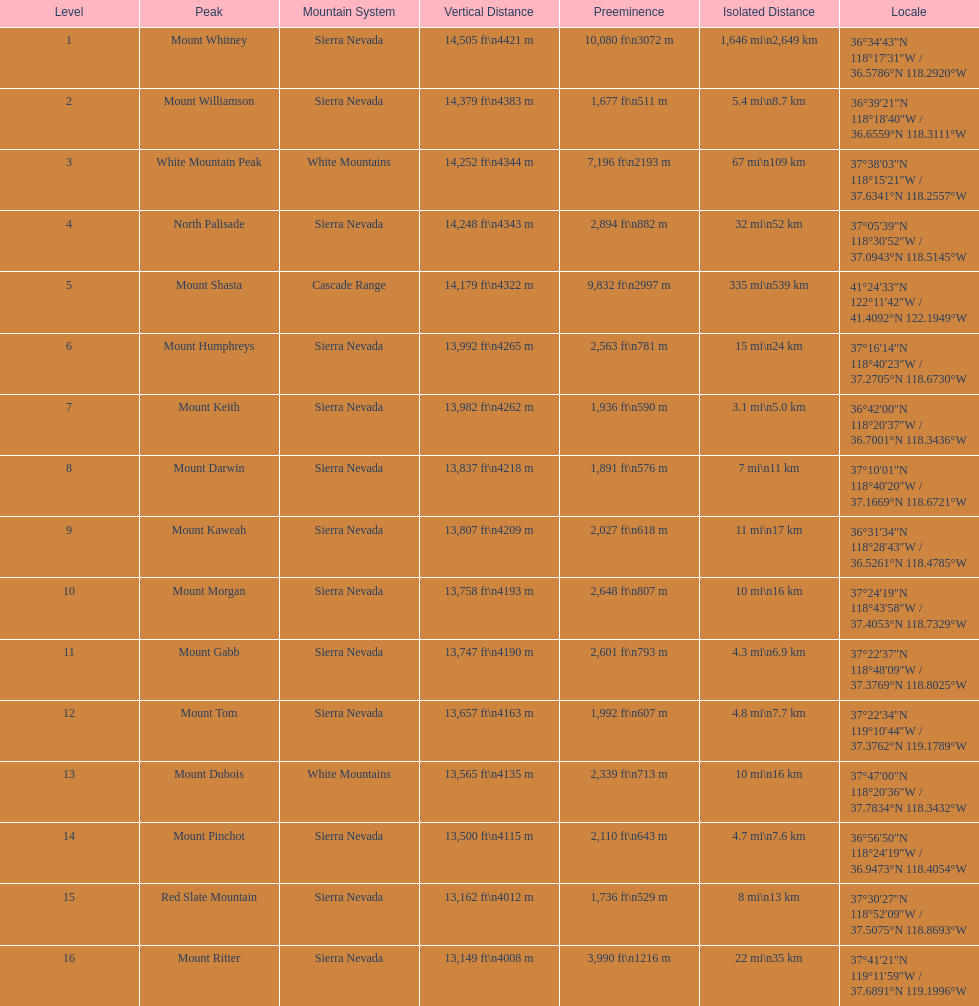Parse the full table. {'header': ['Level', 'Peak', 'Mountain System', 'Vertical Distance', 'Preeminence', 'Isolated Distance', 'Locale'], 'rows': [['1', 'Mount Whitney', 'Sierra Nevada', '14,505\xa0ft\\n4421\xa0m', '10,080\xa0ft\\n3072\xa0m', '1,646\xa0mi\\n2,649\xa0km', '36°34′43″N 118°17′31″W\ufeff / \ufeff36.5786°N 118.2920°W'], ['2', 'Mount Williamson', 'Sierra Nevada', '14,379\xa0ft\\n4383\xa0m', '1,677\xa0ft\\n511\xa0m', '5.4\xa0mi\\n8.7\xa0km', '36°39′21″N 118°18′40″W\ufeff / \ufeff36.6559°N 118.3111°W'], ['3', 'White Mountain Peak', 'White Mountains', '14,252\xa0ft\\n4344\xa0m', '7,196\xa0ft\\n2193\xa0m', '67\xa0mi\\n109\xa0km', '37°38′03″N 118°15′21″W\ufeff / \ufeff37.6341°N 118.2557°W'], ['4', 'North Palisade', 'Sierra Nevada', '14,248\xa0ft\\n4343\xa0m', '2,894\xa0ft\\n882\xa0m', '32\xa0mi\\n52\xa0km', '37°05′39″N 118°30′52″W\ufeff / \ufeff37.0943°N 118.5145°W'], ['5', 'Mount Shasta', 'Cascade Range', '14,179\xa0ft\\n4322\xa0m', '9,832\xa0ft\\n2997\xa0m', '335\xa0mi\\n539\xa0km', '41°24′33″N 122°11′42″W\ufeff / \ufeff41.4092°N 122.1949°W'], ['6', 'Mount Humphreys', 'Sierra Nevada', '13,992\xa0ft\\n4265\xa0m', '2,563\xa0ft\\n781\xa0m', '15\xa0mi\\n24\xa0km', '37°16′14″N 118°40′23″W\ufeff / \ufeff37.2705°N 118.6730°W'], ['7', 'Mount Keith', 'Sierra Nevada', '13,982\xa0ft\\n4262\xa0m', '1,936\xa0ft\\n590\xa0m', '3.1\xa0mi\\n5.0\xa0km', '36°42′00″N 118°20′37″W\ufeff / \ufeff36.7001°N 118.3436°W'], ['8', 'Mount Darwin', 'Sierra Nevada', '13,837\xa0ft\\n4218\xa0m', '1,891\xa0ft\\n576\xa0m', '7\xa0mi\\n11\xa0km', '37°10′01″N 118°40′20″W\ufeff / \ufeff37.1669°N 118.6721°W'], ['9', 'Mount Kaweah', 'Sierra Nevada', '13,807\xa0ft\\n4209\xa0m', '2,027\xa0ft\\n618\xa0m', '11\xa0mi\\n17\xa0km', '36°31′34″N 118°28′43″W\ufeff / \ufeff36.5261°N 118.4785°W'], ['10', 'Mount Morgan', 'Sierra Nevada', '13,758\xa0ft\\n4193\xa0m', '2,648\xa0ft\\n807\xa0m', '10\xa0mi\\n16\xa0km', '37°24′19″N 118°43′58″W\ufeff / \ufeff37.4053°N 118.7329°W'], ['11', 'Mount Gabb', 'Sierra Nevada', '13,747\xa0ft\\n4190\xa0m', '2,601\xa0ft\\n793\xa0m', '4.3\xa0mi\\n6.9\xa0km', '37°22′37″N 118°48′09″W\ufeff / \ufeff37.3769°N 118.8025°W'], ['12', 'Mount Tom', 'Sierra Nevada', '13,657\xa0ft\\n4163\xa0m', '1,992\xa0ft\\n607\xa0m', '4.8\xa0mi\\n7.7\xa0km', '37°22′34″N 119°10′44″W\ufeff / \ufeff37.3762°N 119.1789°W'], ['13', 'Mount Dubois', 'White Mountains', '13,565\xa0ft\\n4135\xa0m', '2,339\xa0ft\\n713\xa0m', '10\xa0mi\\n16\xa0km', '37°47′00″N 118°20′36″W\ufeff / \ufeff37.7834°N 118.3432°W'], ['14', 'Mount Pinchot', 'Sierra Nevada', '13,500\xa0ft\\n4115\xa0m', '2,110\xa0ft\\n643\xa0m', '4.7\xa0mi\\n7.6\xa0km', '36°56′50″N 118°24′19″W\ufeff / \ufeff36.9473°N 118.4054°W'], ['15', 'Red Slate Mountain', 'Sierra Nevada', '13,162\xa0ft\\n4012\xa0m', '1,736\xa0ft\\n529\xa0m', '8\xa0mi\\n13\xa0km', '37°30′27″N 118°52′09″W\ufeff / \ufeff37.5075°N 118.8693°W'], ['16', 'Mount Ritter', 'Sierra Nevada', '13,149\xa0ft\\n4008\xa0m', '3,990\xa0ft\\n1216\xa0m', '22\xa0mi\\n35\xa0km', '37°41′21″N 119°11′59″W\ufeff / \ufeff37.6891°N 119.1996°W']]} In feet, what is the difference between the tallest peak and the 9th tallest peak in california? 698 ft. 